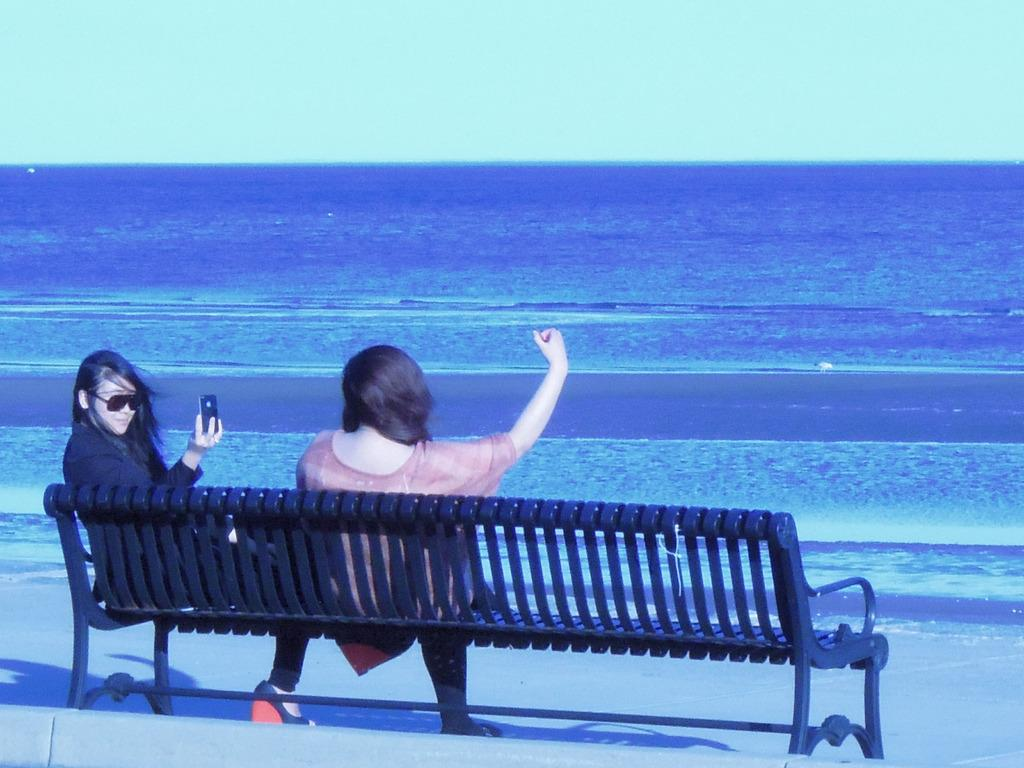What are the women in the image doing? The women are sitting on a bench in the image. Can you describe what one of the women is holding? One of the women is holding a mobile phone. What can be seen in the background of the image? There is a sea and the sky visible in the background of the image. What type of arch can be seen in the image? There is no arch present in the image. What disease might the women be discussing on the bench? We cannot determine any diseases from the image, as it only shows women sitting on a bench and one holding a mobile phone. 